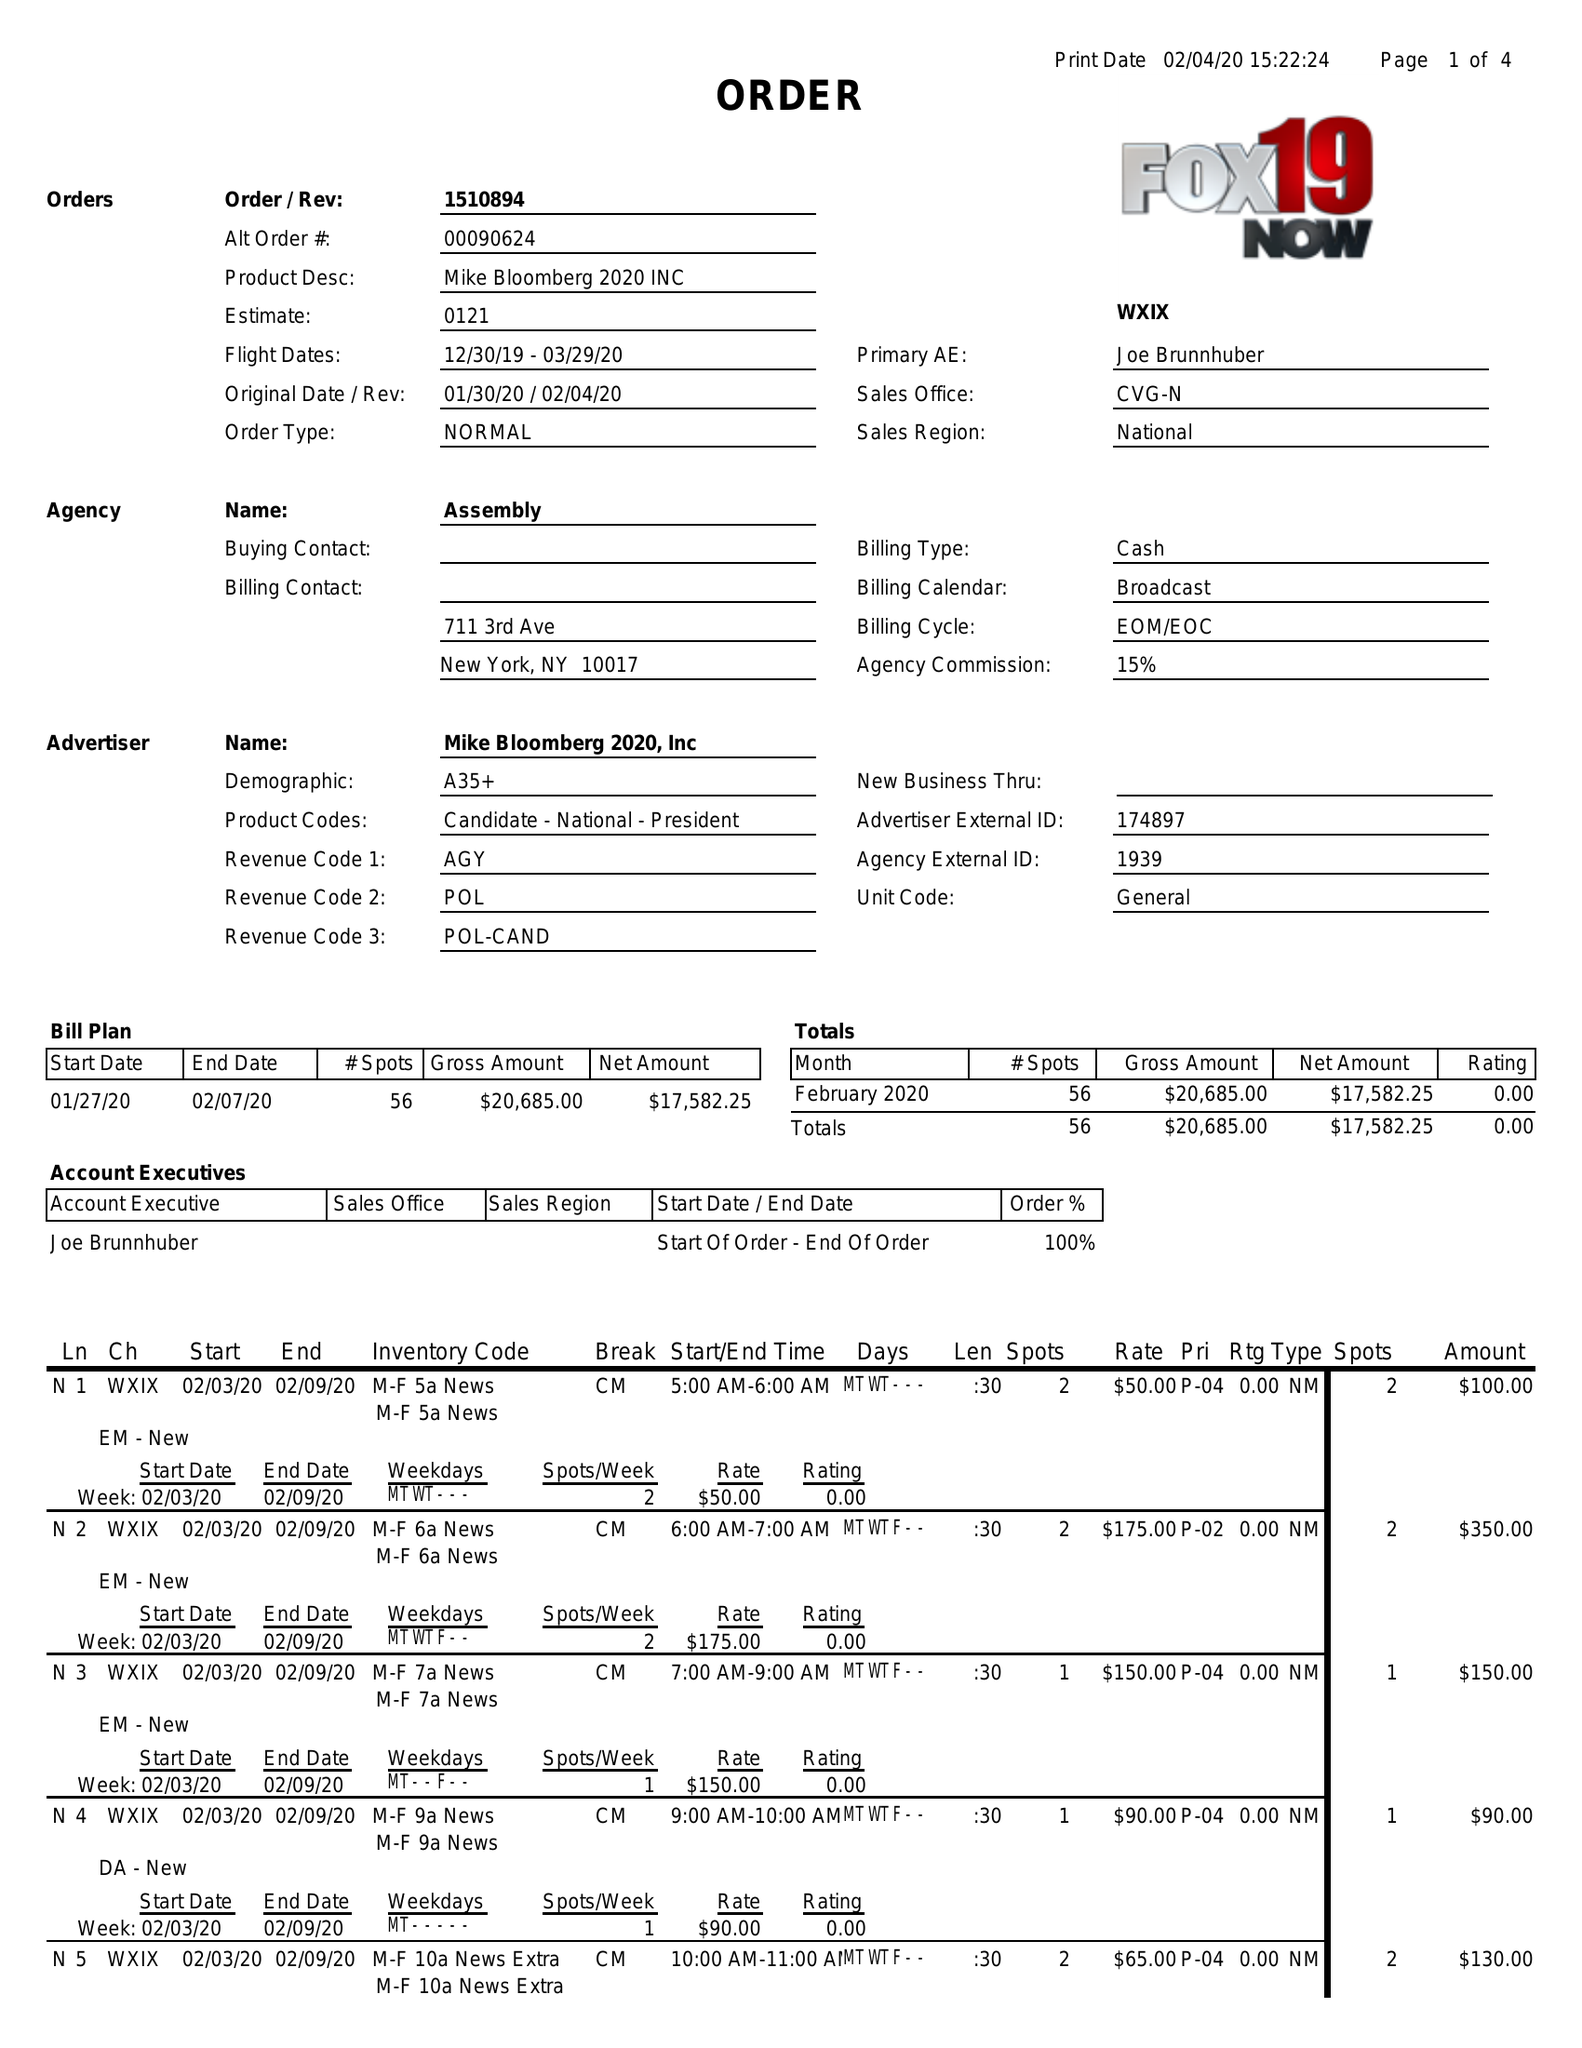What is the value for the gross_amount?
Answer the question using a single word or phrase. 20685.00 